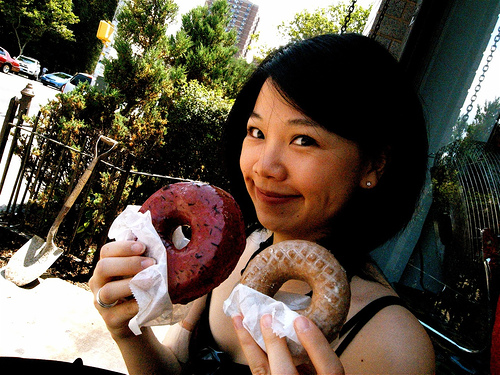What flavors do the donuts appear to be? The donuts in the image seem to be of two different flavors. The one in the left hand, with its dark reddish-brown color and sprinkles, could be red velvet, while the one in the right hand, with its lighter brown hue, might be a classic glazed. 